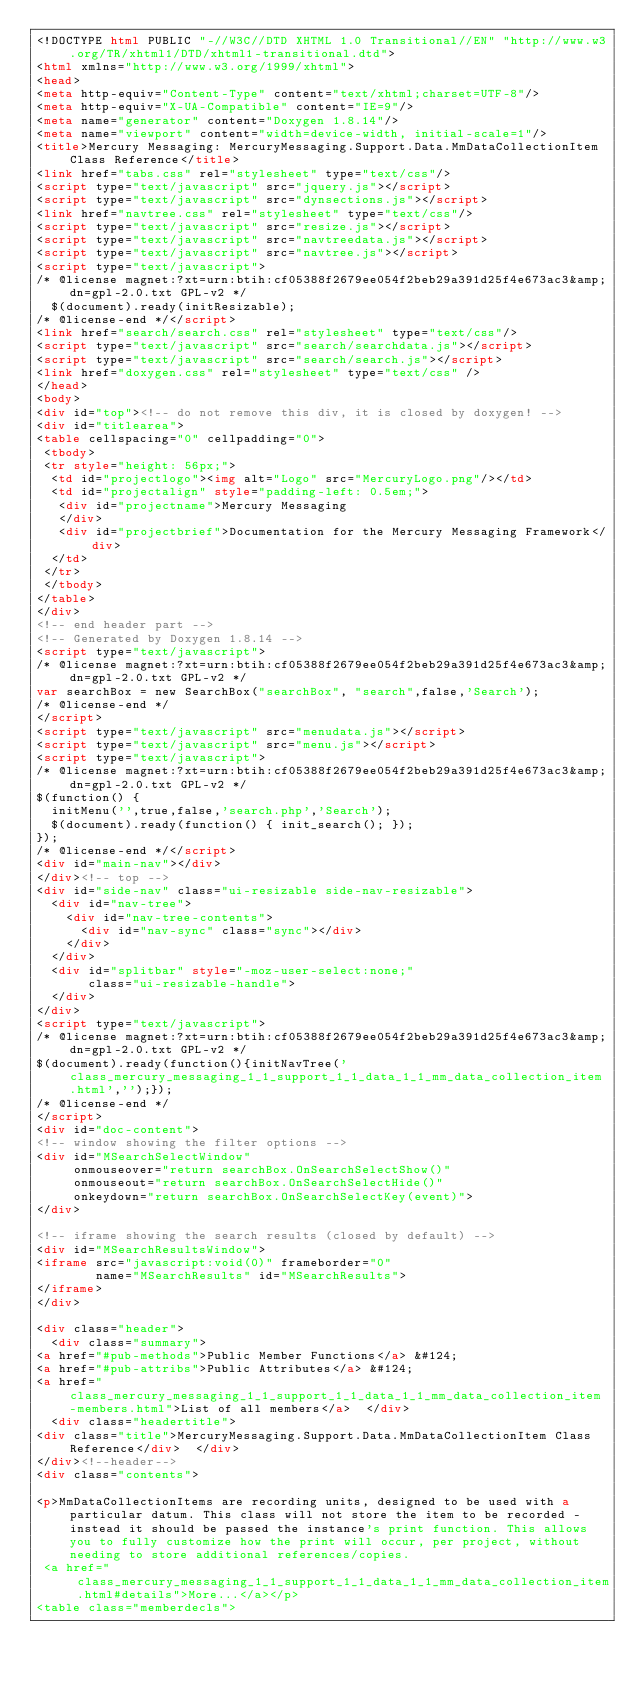Convert code to text. <code><loc_0><loc_0><loc_500><loc_500><_HTML_><!DOCTYPE html PUBLIC "-//W3C//DTD XHTML 1.0 Transitional//EN" "http://www.w3.org/TR/xhtml1/DTD/xhtml1-transitional.dtd">
<html xmlns="http://www.w3.org/1999/xhtml">
<head>
<meta http-equiv="Content-Type" content="text/xhtml;charset=UTF-8"/>
<meta http-equiv="X-UA-Compatible" content="IE=9"/>
<meta name="generator" content="Doxygen 1.8.14"/>
<meta name="viewport" content="width=device-width, initial-scale=1"/>
<title>Mercury Messaging: MercuryMessaging.Support.Data.MmDataCollectionItem Class Reference</title>
<link href="tabs.css" rel="stylesheet" type="text/css"/>
<script type="text/javascript" src="jquery.js"></script>
<script type="text/javascript" src="dynsections.js"></script>
<link href="navtree.css" rel="stylesheet" type="text/css"/>
<script type="text/javascript" src="resize.js"></script>
<script type="text/javascript" src="navtreedata.js"></script>
<script type="text/javascript" src="navtree.js"></script>
<script type="text/javascript">
/* @license magnet:?xt=urn:btih:cf05388f2679ee054f2beb29a391d25f4e673ac3&amp;dn=gpl-2.0.txt GPL-v2 */
  $(document).ready(initResizable);
/* @license-end */</script>
<link href="search/search.css" rel="stylesheet" type="text/css"/>
<script type="text/javascript" src="search/searchdata.js"></script>
<script type="text/javascript" src="search/search.js"></script>
<link href="doxygen.css" rel="stylesheet" type="text/css" />
</head>
<body>
<div id="top"><!-- do not remove this div, it is closed by doxygen! -->
<div id="titlearea">
<table cellspacing="0" cellpadding="0">
 <tbody>
 <tr style="height: 56px;">
  <td id="projectlogo"><img alt="Logo" src="MercuryLogo.png"/></td>
  <td id="projectalign" style="padding-left: 0.5em;">
   <div id="projectname">Mercury Messaging
   </div>
   <div id="projectbrief">Documentation for the Mercury Messaging Framework</div>
  </td>
 </tr>
 </tbody>
</table>
</div>
<!-- end header part -->
<!-- Generated by Doxygen 1.8.14 -->
<script type="text/javascript">
/* @license magnet:?xt=urn:btih:cf05388f2679ee054f2beb29a391d25f4e673ac3&amp;dn=gpl-2.0.txt GPL-v2 */
var searchBox = new SearchBox("searchBox", "search",false,'Search');
/* @license-end */
</script>
<script type="text/javascript" src="menudata.js"></script>
<script type="text/javascript" src="menu.js"></script>
<script type="text/javascript">
/* @license magnet:?xt=urn:btih:cf05388f2679ee054f2beb29a391d25f4e673ac3&amp;dn=gpl-2.0.txt GPL-v2 */
$(function() {
  initMenu('',true,false,'search.php','Search');
  $(document).ready(function() { init_search(); });
});
/* @license-end */</script>
<div id="main-nav"></div>
</div><!-- top -->
<div id="side-nav" class="ui-resizable side-nav-resizable">
  <div id="nav-tree">
    <div id="nav-tree-contents">
      <div id="nav-sync" class="sync"></div>
    </div>
  </div>
  <div id="splitbar" style="-moz-user-select:none;" 
       class="ui-resizable-handle">
  </div>
</div>
<script type="text/javascript">
/* @license magnet:?xt=urn:btih:cf05388f2679ee054f2beb29a391d25f4e673ac3&amp;dn=gpl-2.0.txt GPL-v2 */
$(document).ready(function(){initNavTree('class_mercury_messaging_1_1_support_1_1_data_1_1_mm_data_collection_item.html','');});
/* @license-end */
</script>
<div id="doc-content">
<!-- window showing the filter options -->
<div id="MSearchSelectWindow"
     onmouseover="return searchBox.OnSearchSelectShow()"
     onmouseout="return searchBox.OnSearchSelectHide()"
     onkeydown="return searchBox.OnSearchSelectKey(event)">
</div>

<!-- iframe showing the search results (closed by default) -->
<div id="MSearchResultsWindow">
<iframe src="javascript:void(0)" frameborder="0" 
        name="MSearchResults" id="MSearchResults">
</iframe>
</div>

<div class="header">
  <div class="summary">
<a href="#pub-methods">Public Member Functions</a> &#124;
<a href="#pub-attribs">Public Attributes</a> &#124;
<a href="class_mercury_messaging_1_1_support_1_1_data_1_1_mm_data_collection_item-members.html">List of all members</a>  </div>
  <div class="headertitle">
<div class="title">MercuryMessaging.Support.Data.MmDataCollectionItem Class Reference</div>  </div>
</div><!--header-->
<div class="contents">

<p>MmDataCollectionItems are recording units, designed to be used with a particular datum. This class will not store the item to be recorded - instead it should be passed the instance's print function. This allows you to fully customize how the print will occur, per project, without needing to store additional references/copies.  
 <a href="class_mercury_messaging_1_1_support_1_1_data_1_1_mm_data_collection_item.html#details">More...</a></p>
<table class="memberdecls"></code> 